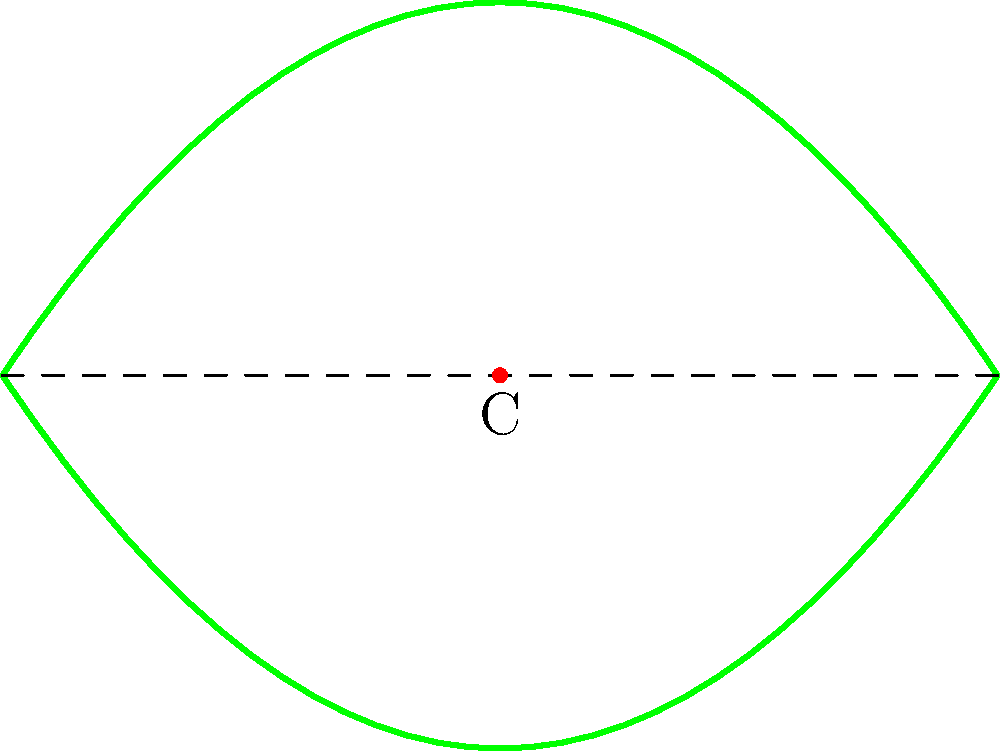In the diagram above, a simplified coffee leaf pattern is shown. The leaf exhibits bilateral symmetry along the central vein. If we consider the symmetry group of this pattern, what is the order of the rotational symmetry about point C? Let's analyze the symmetry of the coffee leaf pattern step-by-step:

1. The leaf has bilateral symmetry along the central vein (dashed line).

2. Point C is located at the center of the leaf on the central vein.

3. To determine the order of rotational symmetry about point C, we need to consider how many distinct positions the leaf can have when rotated around C that will result in the same pattern.

4. In this case, we can observe that:
   a) A 360° (full) rotation brings the leaf back to its original position.
   b) A 180° rotation also brings the leaf back to its original position due to the bilateral symmetry.

5. No other rotation (e.g., 90°, 120°, etc.) will result in the same pattern.

6. Therefore, there are only two distinct positions: the original position and the position after a 180° rotation.

7. The order of rotational symmetry is defined as the number of distinct positions under rotation.

Thus, the order of rotational symmetry about point C is 2.
Answer: 2 